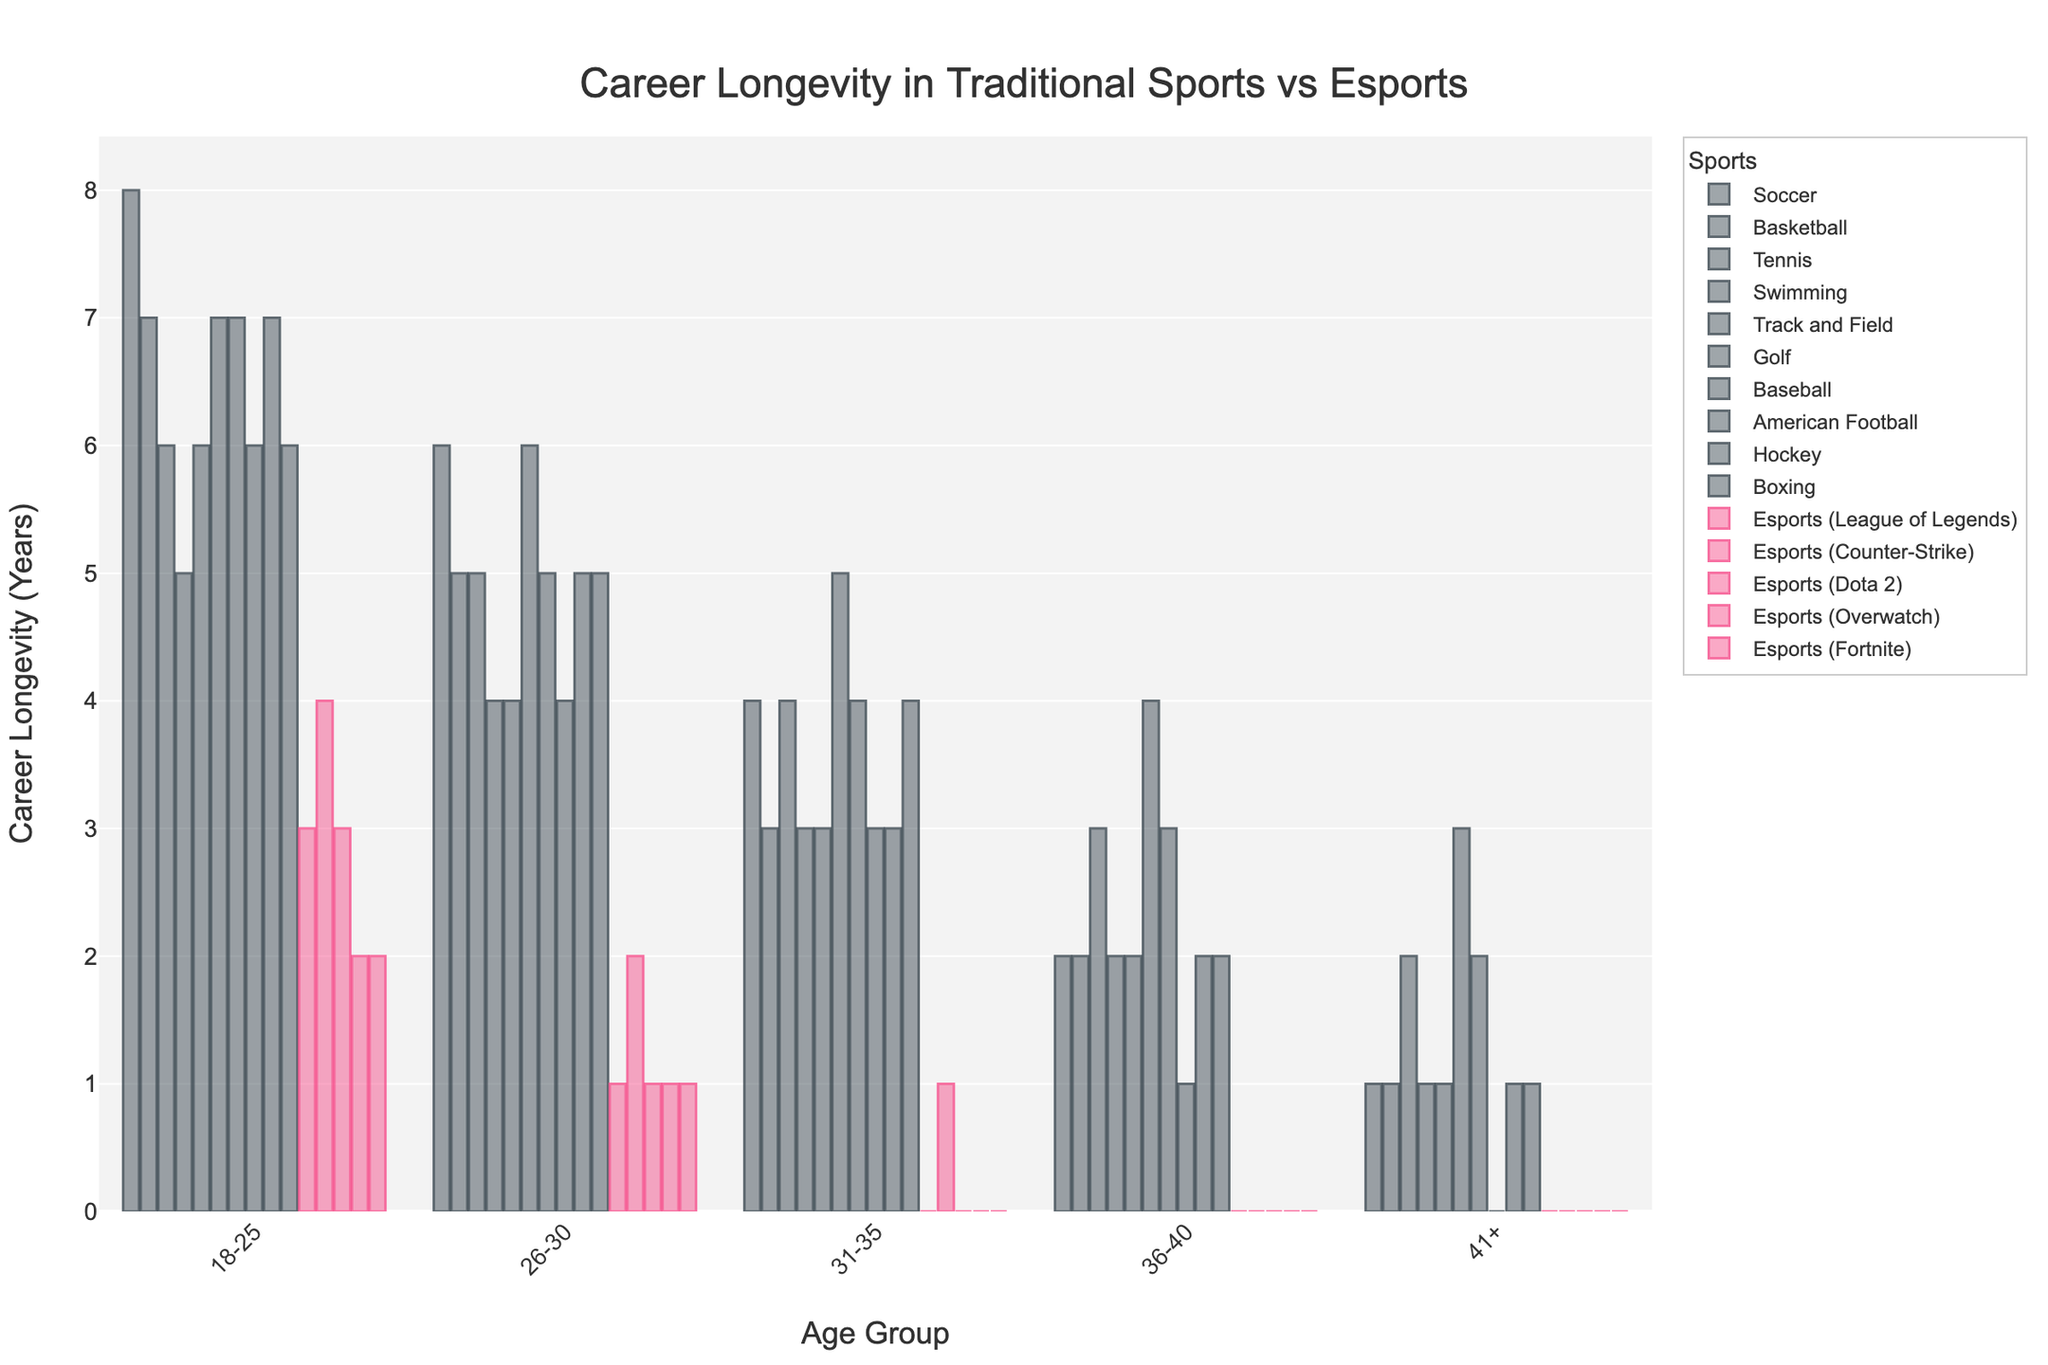What is the career longevity for Soccer players in the 18-25 age group? We look at the bar representing Soccer in the 18-25 age group. The height of the bar indicates a career longevity of 8 years.
Answer: 8 years Which sport has the shortest career longevity in the 36-40 age group? We compare the bars for all sports in the 36-40 age group. Esports (League of Legends), Esports (Counter-Strike), Esports (Dota 2), Esports (Overwatch), and Esports (Fortnite) all have a career longevity of 0 years, which is the shortest.
Answer: Esports (League of Legends), Esports (Counter-Strike), Esports (Dota 2), Esports (Overwatch), Esports (Fortnite) What is the total career longevity of Basketball players across all age groups? Sum the career longevity values for Basketball across all age groups: 7 (18-25) + 5 (26-30) + 3 (31-35) + 2 (36-40) + 1 (41+). Thus, 7+5+3+2+1 = 18.
Answer: 18 years Which age group has the highest average career longevity across all traditional sports? Calculate the average for each age group in traditional sports:
- 18-25: (8+7+6+5+6+7+7+6+7+6)/10 = 6.5
- 26-30: (6+5+5+4+4+6+5+4+5+5)/10 = 4.9
- 31-35: (4+3+4+3+3+5+4+3+3+4)/10 = 3.6
- 36-40: (2+2+3+2+2+4+3+1+2+2)/10 = 2.3
- 41+: (1+1+2+1+1+3+2+0+1+1)/10 = 1.3
18-25 has the highest average career longevity.
Answer: 18-25 How does the career longevity of Golf players compare to Esports (League of Legends) players in the 41+ age group? Compare the bars for Golf and Esports (League of Legends) in the 41+ age group. Golf players have a career longevity of 3 years, while Esports (League of Legends) players have 0 years.
Answer: Golf players have longer career longevity In which age group do Esports (Counter-Strike) players have the highest career longevity, and what is it? Compare the bars for Esports (Counter-Strike) in each age group. The highest bar is in the 18-25 age group, with a career longevity of 4 years.
Answer: 18-25, 4 years Which traditional sport shows the least decline in career longevity from the 18-25 to the 41+ age group? Calculate the decline for each traditional sport:
- Soccer: 8-1 = 7
- Basketball: 7-1 = 6
- Tennis: 6-2 = 4
- Swimming: 5-1 = 4
- Track and Field: 6-1 = 5
- Golf: 7-3 = 4
- Baseball: 7-2 = 5
- American Football: 6-0 = 6
- Hockey: 7-1 = 6
- Boxing: 6-1 = 5
Golf, Tennis, and Swimming have the least decline of 4 years.
Answer: Tennis, Swimming, Golf Which sport has no career longevity for age groups 31-35, 36-40, and 41+? Check for the bar heights of each sport in these age groups. Esports (League of Legends), Esports (Dota 2), Esports (Overwatch), and Esports (Fortnite) have no career longevity in these age groups.
Answer: Esports (League of Legends, Dota 2, Overwatch, Fortnite) What is the average career longevity of traditional sports players in the 26-30 age group? Calculate the average by summing the career longevity for the 26-30 age group in traditional sports and dividing by number of sports:
- Traditional sports total: 6+5+5+4+4+6+5+4+5+5 = 49
- Number of traditional sports: 10
Thus, 49/10 = 4.9.
Answer: 4.9 years 